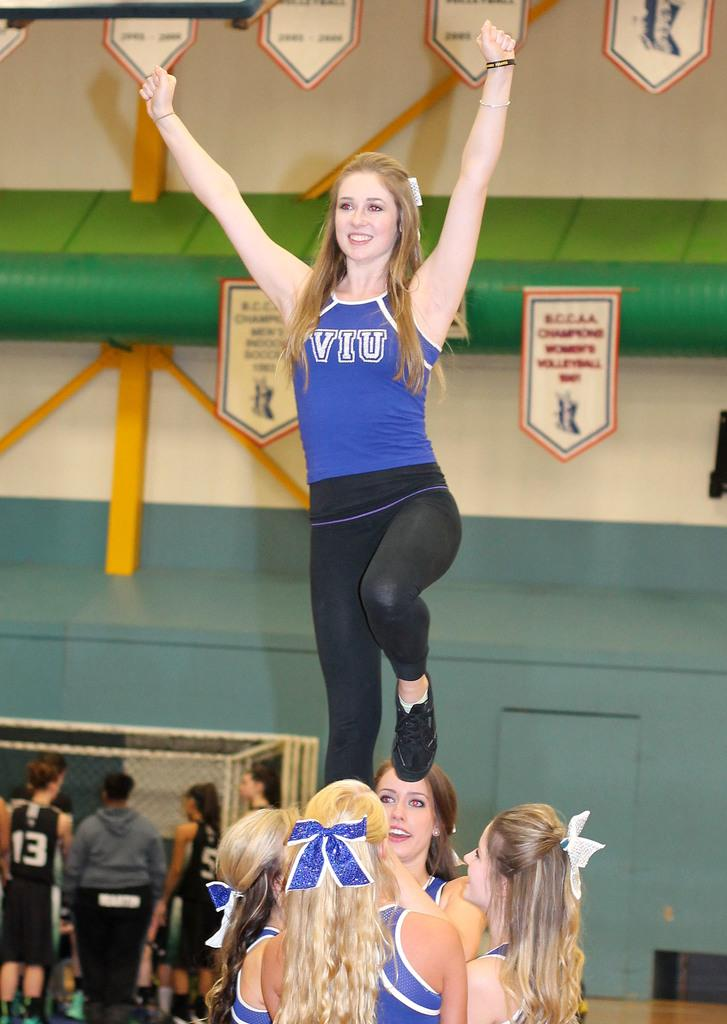<image>
Provide a brief description of the given image. A cheerleader for VIU is held up in a pyramid. 